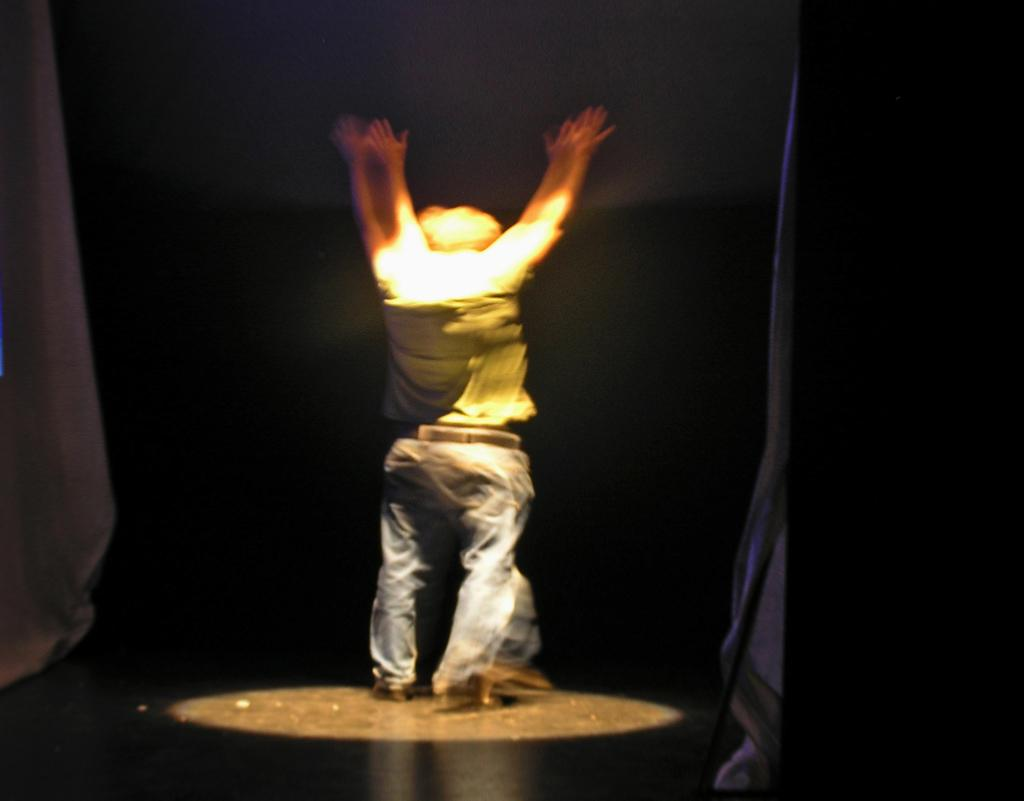What is the main subject of the image? There is a person standing in the image. What is the person doing in the image? The person is raising his hands. What can be seen illuminating the person in the image? There is a spotlight on the person. What color is the background of the image? The background of the image is black. Reasoning: Let'g: Let's think step by step in order to produce the conversation. We start by identifying the main subject of the image, which is the person standing. Then, we describe the person's actions, noting that they are raising their hands. Next, we mention the spotlight that is illuminating the person, providing additional context to the scene. Finally, we describe the background color, which is black. Absurd Question/Answer: What type of pancake is being flipped by the farmer in the stream in the image? There is no pancake, farmer, or stream present in the image. 